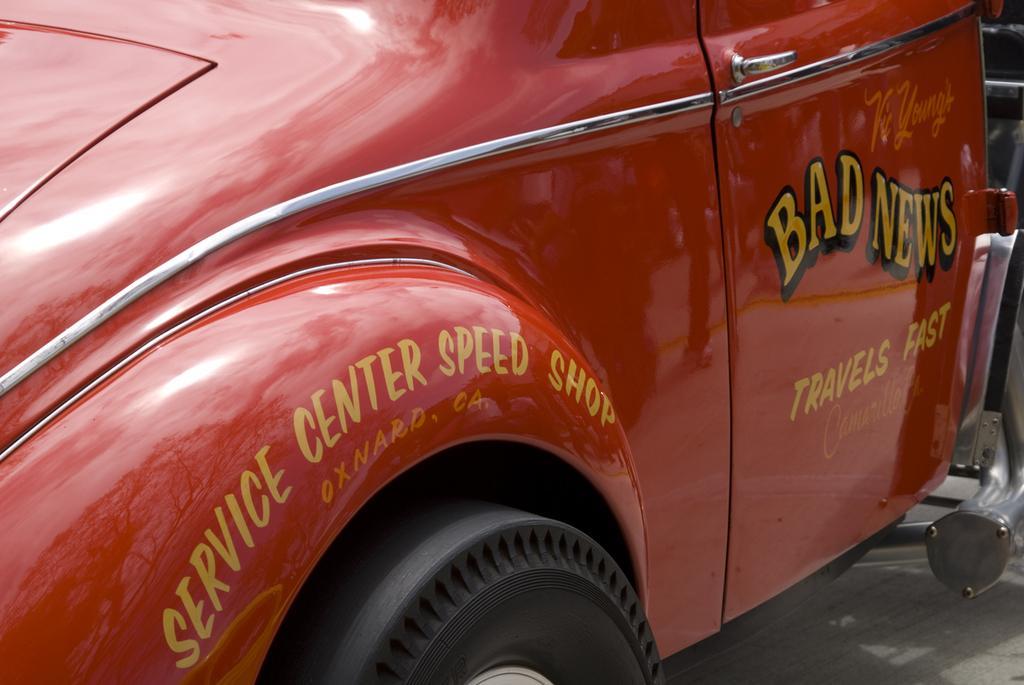In one or two sentences, can you explain what this image depicts? In this picture there is a vehicle on the road and there is text on the vehicle and there is a reflection of tree and sky and other objects on the vehicle and there is a handle on the door. At the bottom there is a black wheel. 